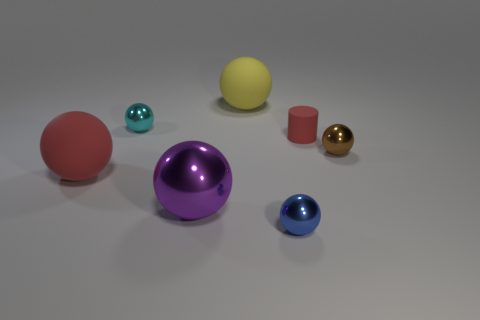What shape is the large matte thing left of the big rubber thing on the right side of the matte ball in front of the brown sphere?
Provide a succinct answer. Sphere. There is a rubber object that is the same color as the tiny cylinder; what shape is it?
Make the answer very short. Sphere. There is a big object that is both behind the purple metal object and right of the red rubber sphere; what material is it?
Ensure brevity in your answer.  Rubber. Is the number of large purple shiny things less than the number of tiny red balls?
Your response must be concise. No. Does the tiny brown thing have the same shape as the big rubber thing that is behind the big red object?
Offer a terse response. Yes. There is a red object left of the purple object; does it have the same size as the tiny cylinder?
Provide a short and direct response. No. What shape is the metallic object that is the same size as the red sphere?
Provide a succinct answer. Sphere. Is the big purple metallic thing the same shape as the brown thing?
Give a very brief answer. Yes. What number of big purple metal objects are the same shape as the cyan shiny thing?
Keep it short and to the point. 1. There is a blue sphere; what number of small metallic objects are in front of it?
Make the answer very short. 0. 